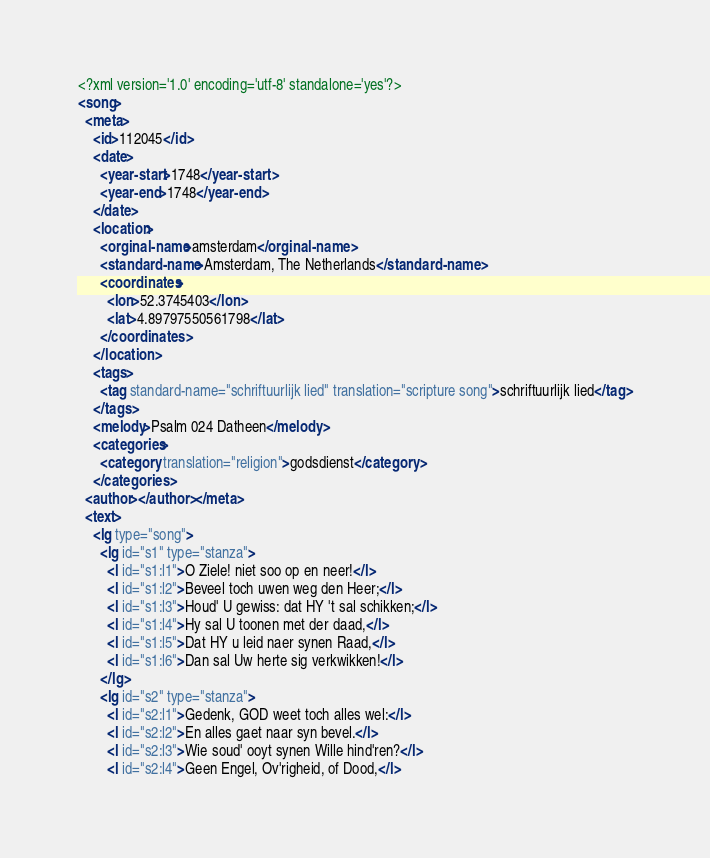<code> <loc_0><loc_0><loc_500><loc_500><_XML_><?xml version='1.0' encoding='utf-8' standalone='yes'?>
<song>
  <meta>
    <id>112045</id>
    <date>
      <year-start>1748</year-start>
      <year-end>1748</year-end>
    </date>
    <location>
      <orginal-name>amsterdam</orginal-name>
      <standard-name>Amsterdam, The Netherlands</standard-name>
      <coordinates>
        <lon>52.3745403</lon>
        <lat>4.89797550561798</lat>
      </coordinates>
    </location>
    <tags>
      <tag standard-name="schriftuurlijk lied" translation="scripture song">schriftuurlijk lied</tag>
    </tags>
    <melody>Psalm 024 Datheen</melody>
    <categories>
      <category translation="religion">godsdienst</category>
    </categories>
  <author></author></meta>
  <text>
    <lg type="song">
      <lg id="s1" type="stanza">
        <l id="s1:l1">O Ziele! niet soo op en neer!</l>
        <l id="s1:l2">Beveel toch uwen weg den Heer;</l>
        <l id="s1:l3">Houd' U gewiss: dat HY 't sal schikken;</l>
        <l id="s1:l4">Hy sal U toonen met der daad,</l>
        <l id="s1:l5">Dat HY u leid naer synen Raad,</l>
        <l id="s1:l6">Dan sal Uw herte sig verkwikken!</l>
      </lg>
      <lg id="s2" type="stanza">
        <l id="s2:l1">Gedenk, GOD weet toch alles wel:</l>
        <l id="s2:l2">En alles gaet naar syn bevel.</l>
        <l id="s2:l3">Wie soud' ooyt synen Wille hind'ren?</l>
        <l id="s2:l4">Geen Engel, Ov'righeid, of Dood,</l></code> 